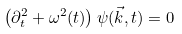<formula> <loc_0><loc_0><loc_500><loc_500>\left ( \partial _ { t } ^ { 2 } + \omega ^ { 2 } ( t ) \right ) \psi ( \vec { k } , t ) = 0 \,</formula> 